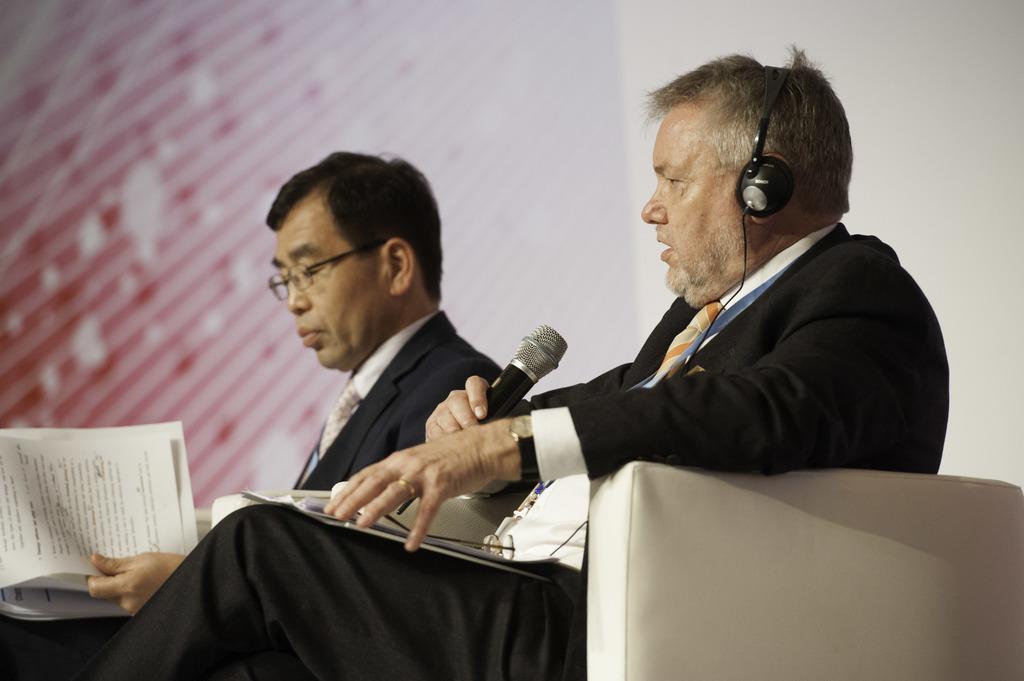In one or two sentences, can you explain what this image depicts? In this image there are two persons sitting on a sofa, one of them is holding a mic and wearing a headset on his head and he placed a few papers on his lap. The other person holding papers in his hands. In the background there is a wall. 